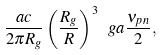<formula> <loc_0><loc_0><loc_500><loc_500>\frac { a c } { 2 \pi R _ { g } } \left ( \frac { R _ { g } } { R } \right ) ^ { 3 } \ g a \frac { \nu _ { p n } } { 2 } ,</formula> 